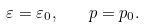<formula> <loc_0><loc_0><loc_500><loc_500>\varepsilon = \varepsilon _ { 0 } , \quad p = p _ { 0 } .</formula> 